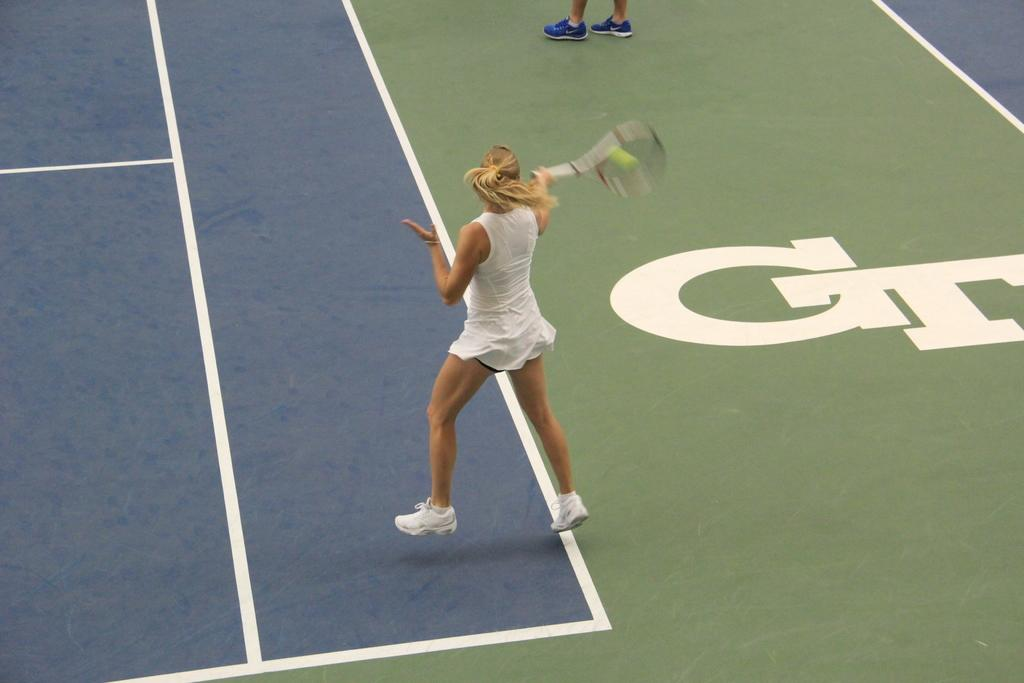Who or what is the main subject in the image? There is a person in the image. What is the person wearing? The person is wearing clothes. What activity is the person engaged in? The person is playing tennis. What object is the person holding while playing tennis? The person is holding a tennis racket with her hand. What type of crate is visible in the image? There is no crate present in the image. What color is the person's hair in the image? The provided facts do not mention the person's hair color, so it cannot be determined from the image. 